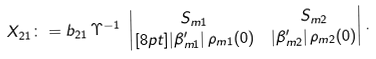<formula> <loc_0><loc_0><loc_500><loc_500>X _ { 2 1 } & \colon = b _ { 2 1 } \, \Upsilon ^ { - 1 } \ \left | \begin{matrix} S _ { m 1 } & S _ { m 2 } \\ [ 8 p t ] | \beta _ { m 1 } ^ { \prime } | \, \rho _ { m 1 } ( 0 ) & | \beta _ { m 2 } ^ { \prime } | \, \rho _ { m 2 } ( 0 ) \end{matrix} \right | .</formula> 